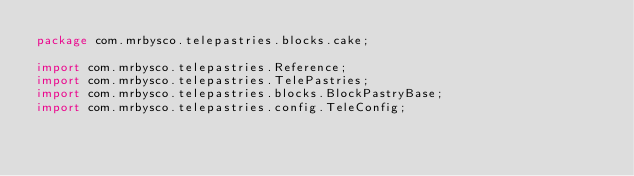Convert code to text. <code><loc_0><loc_0><loc_500><loc_500><_Java_>package com.mrbysco.telepastries.blocks.cake;

import com.mrbysco.telepastries.Reference;
import com.mrbysco.telepastries.TelePastries;
import com.mrbysco.telepastries.blocks.BlockPastryBase;
import com.mrbysco.telepastries.config.TeleConfig;</code> 